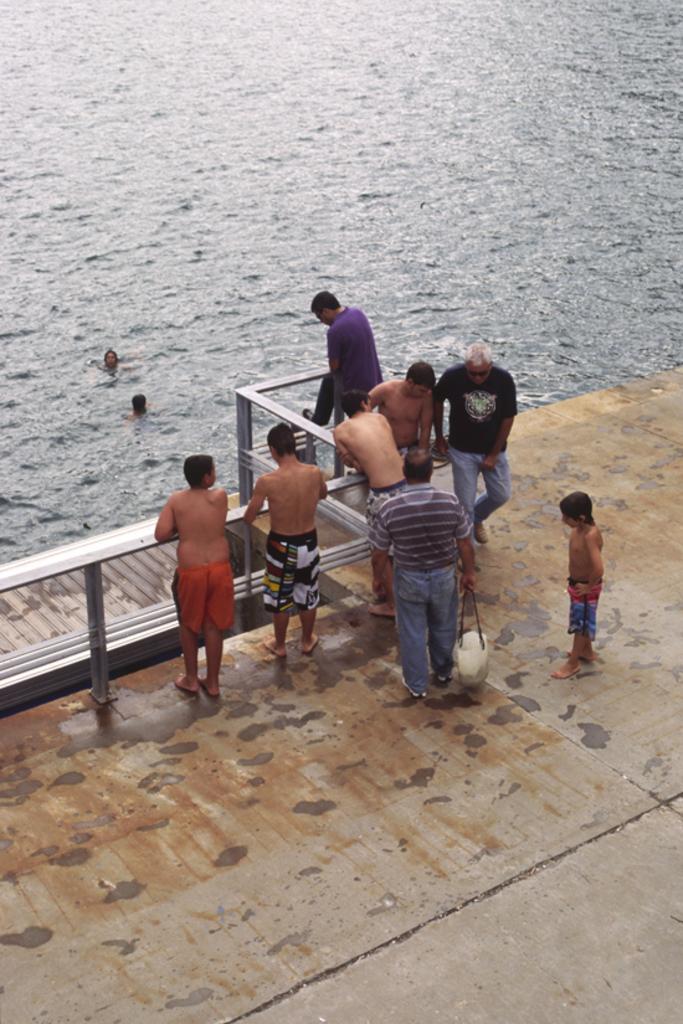Please provide a concise description of this image. In this image we can see a floor. And there is a railing. And there are few people standing. One person is holding something in the hand. Also there is water. And there are two persons in the water. 